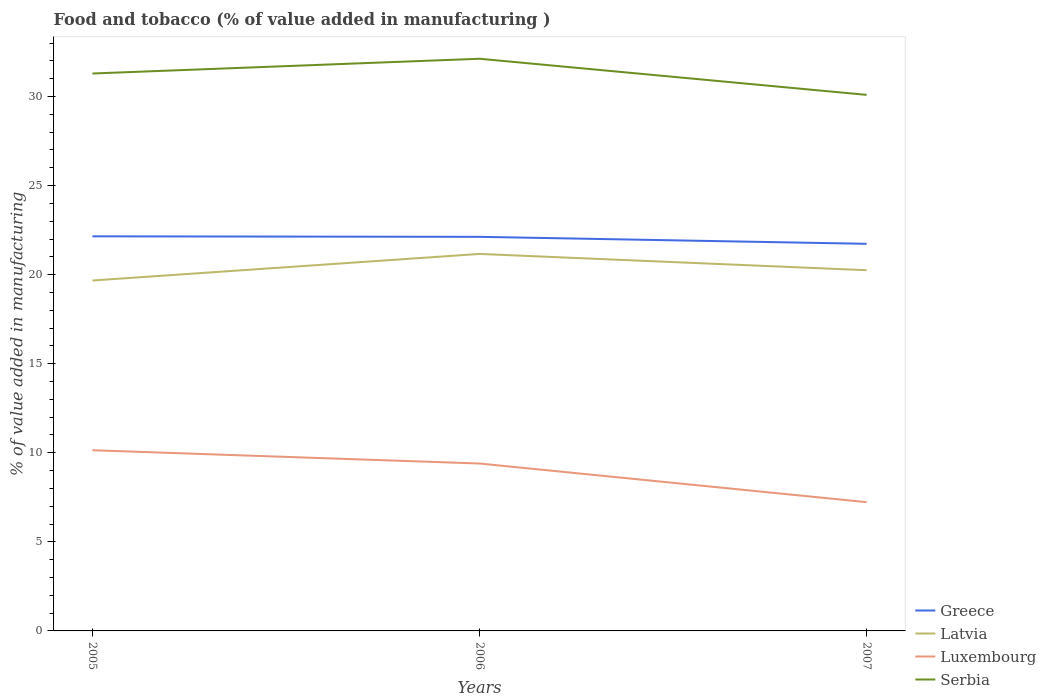How many different coloured lines are there?
Keep it short and to the point. 4. Is the number of lines equal to the number of legend labels?
Provide a succinct answer. Yes. Across all years, what is the maximum value added in manufacturing food and tobacco in Luxembourg?
Your answer should be very brief. 7.23. In which year was the value added in manufacturing food and tobacco in Greece maximum?
Give a very brief answer. 2007. What is the total value added in manufacturing food and tobacco in Luxembourg in the graph?
Provide a succinct answer. 2.91. What is the difference between the highest and the second highest value added in manufacturing food and tobacco in Serbia?
Offer a very short reply. 2.03. How many lines are there?
Your answer should be very brief. 4. What is the difference between two consecutive major ticks on the Y-axis?
Give a very brief answer. 5. Are the values on the major ticks of Y-axis written in scientific E-notation?
Your answer should be compact. No. What is the title of the graph?
Make the answer very short. Food and tobacco (% of value added in manufacturing ). What is the label or title of the Y-axis?
Offer a terse response. % of value added in manufacturing. What is the % of value added in manufacturing of Greece in 2005?
Keep it short and to the point. 22.15. What is the % of value added in manufacturing in Latvia in 2005?
Offer a terse response. 19.67. What is the % of value added in manufacturing of Luxembourg in 2005?
Your answer should be compact. 10.14. What is the % of value added in manufacturing of Serbia in 2005?
Make the answer very short. 31.29. What is the % of value added in manufacturing in Greece in 2006?
Make the answer very short. 22.12. What is the % of value added in manufacturing of Latvia in 2006?
Offer a very short reply. 21.16. What is the % of value added in manufacturing in Luxembourg in 2006?
Provide a short and direct response. 9.4. What is the % of value added in manufacturing of Serbia in 2006?
Your answer should be very brief. 32.12. What is the % of value added in manufacturing in Greece in 2007?
Provide a short and direct response. 21.73. What is the % of value added in manufacturing of Latvia in 2007?
Your response must be concise. 20.25. What is the % of value added in manufacturing of Luxembourg in 2007?
Offer a terse response. 7.23. What is the % of value added in manufacturing of Serbia in 2007?
Make the answer very short. 30.09. Across all years, what is the maximum % of value added in manufacturing in Greece?
Offer a terse response. 22.15. Across all years, what is the maximum % of value added in manufacturing in Latvia?
Ensure brevity in your answer.  21.16. Across all years, what is the maximum % of value added in manufacturing in Luxembourg?
Give a very brief answer. 10.14. Across all years, what is the maximum % of value added in manufacturing of Serbia?
Provide a succinct answer. 32.12. Across all years, what is the minimum % of value added in manufacturing of Greece?
Keep it short and to the point. 21.73. Across all years, what is the minimum % of value added in manufacturing in Latvia?
Provide a short and direct response. 19.67. Across all years, what is the minimum % of value added in manufacturing of Luxembourg?
Offer a very short reply. 7.23. Across all years, what is the minimum % of value added in manufacturing of Serbia?
Your answer should be very brief. 30.09. What is the total % of value added in manufacturing of Greece in the graph?
Make the answer very short. 66.01. What is the total % of value added in manufacturing in Latvia in the graph?
Offer a very short reply. 61.08. What is the total % of value added in manufacturing of Luxembourg in the graph?
Provide a short and direct response. 26.77. What is the total % of value added in manufacturing in Serbia in the graph?
Ensure brevity in your answer.  93.51. What is the difference between the % of value added in manufacturing of Greece in 2005 and that in 2006?
Keep it short and to the point. 0.03. What is the difference between the % of value added in manufacturing in Latvia in 2005 and that in 2006?
Provide a short and direct response. -1.49. What is the difference between the % of value added in manufacturing in Luxembourg in 2005 and that in 2006?
Make the answer very short. 0.75. What is the difference between the % of value added in manufacturing of Serbia in 2005 and that in 2006?
Ensure brevity in your answer.  -0.83. What is the difference between the % of value added in manufacturing in Greece in 2005 and that in 2007?
Make the answer very short. 0.42. What is the difference between the % of value added in manufacturing of Latvia in 2005 and that in 2007?
Give a very brief answer. -0.58. What is the difference between the % of value added in manufacturing of Luxembourg in 2005 and that in 2007?
Your answer should be very brief. 2.91. What is the difference between the % of value added in manufacturing of Serbia in 2005 and that in 2007?
Your response must be concise. 1.2. What is the difference between the % of value added in manufacturing in Greece in 2006 and that in 2007?
Provide a short and direct response. 0.39. What is the difference between the % of value added in manufacturing in Latvia in 2006 and that in 2007?
Your answer should be very brief. 0.91. What is the difference between the % of value added in manufacturing of Luxembourg in 2006 and that in 2007?
Offer a terse response. 2.17. What is the difference between the % of value added in manufacturing of Serbia in 2006 and that in 2007?
Ensure brevity in your answer.  2.03. What is the difference between the % of value added in manufacturing of Greece in 2005 and the % of value added in manufacturing of Latvia in 2006?
Offer a terse response. 0.99. What is the difference between the % of value added in manufacturing of Greece in 2005 and the % of value added in manufacturing of Luxembourg in 2006?
Offer a very short reply. 12.75. What is the difference between the % of value added in manufacturing in Greece in 2005 and the % of value added in manufacturing in Serbia in 2006?
Give a very brief answer. -9.97. What is the difference between the % of value added in manufacturing of Latvia in 2005 and the % of value added in manufacturing of Luxembourg in 2006?
Offer a terse response. 10.27. What is the difference between the % of value added in manufacturing of Latvia in 2005 and the % of value added in manufacturing of Serbia in 2006?
Provide a short and direct response. -12.45. What is the difference between the % of value added in manufacturing of Luxembourg in 2005 and the % of value added in manufacturing of Serbia in 2006?
Make the answer very short. -21.98. What is the difference between the % of value added in manufacturing of Greece in 2005 and the % of value added in manufacturing of Latvia in 2007?
Give a very brief answer. 1.9. What is the difference between the % of value added in manufacturing in Greece in 2005 and the % of value added in manufacturing in Luxembourg in 2007?
Ensure brevity in your answer.  14.92. What is the difference between the % of value added in manufacturing of Greece in 2005 and the % of value added in manufacturing of Serbia in 2007?
Your answer should be very brief. -7.94. What is the difference between the % of value added in manufacturing of Latvia in 2005 and the % of value added in manufacturing of Luxembourg in 2007?
Offer a very short reply. 12.44. What is the difference between the % of value added in manufacturing in Latvia in 2005 and the % of value added in manufacturing in Serbia in 2007?
Give a very brief answer. -10.42. What is the difference between the % of value added in manufacturing in Luxembourg in 2005 and the % of value added in manufacturing in Serbia in 2007?
Offer a terse response. -19.95. What is the difference between the % of value added in manufacturing of Greece in 2006 and the % of value added in manufacturing of Latvia in 2007?
Provide a succinct answer. 1.87. What is the difference between the % of value added in manufacturing of Greece in 2006 and the % of value added in manufacturing of Luxembourg in 2007?
Offer a terse response. 14.89. What is the difference between the % of value added in manufacturing of Greece in 2006 and the % of value added in manufacturing of Serbia in 2007?
Provide a succinct answer. -7.97. What is the difference between the % of value added in manufacturing in Latvia in 2006 and the % of value added in manufacturing in Luxembourg in 2007?
Your response must be concise. 13.93. What is the difference between the % of value added in manufacturing in Latvia in 2006 and the % of value added in manufacturing in Serbia in 2007?
Provide a short and direct response. -8.93. What is the difference between the % of value added in manufacturing in Luxembourg in 2006 and the % of value added in manufacturing in Serbia in 2007?
Your response must be concise. -20.69. What is the average % of value added in manufacturing of Greece per year?
Offer a terse response. 22. What is the average % of value added in manufacturing of Latvia per year?
Your answer should be compact. 20.36. What is the average % of value added in manufacturing of Luxembourg per year?
Provide a succinct answer. 8.92. What is the average % of value added in manufacturing of Serbia per year?
Offer a terse response. 31.17. In the year 2005, what is the difference between the % of value added in manufacturing in Greece and % of value added in manufacturing in Latvia?
Ensure brevity in your answer.  2.48. In the year 2005, what is the difference between the % of value added in manufacturing in Greece and % of value added in manufacturing in Luxembourg?
Offer a very short reply. 12.01. In the year 2005, what is the difference between the % of value added in manufacturing in Greece and % of value added in manufacturing in Serbia?
Keep it short and to the point. -9.14. In the year 2005, what is the difference between the % of value added in manufacturing in Latvia and % of value added in manufacturing in Luxembourg?
Offer a very short reply. 9.53. In the year 2005, what is the difference between the % of value added in manufacturing in Latvia and % of value added in manufacturing in Serbia?
Provide a short and direct response. -11.62. In the year 2005, what is the difference between the % of value added in manufacturing of Luxembourg and % of value added in manufacturing of Serbia?
Make the answer very short. -21.15. In the year 2006, what is the difference between the % of value added in manufacturing in Greece and % of value added in manufacturing in Latvia?
Your response must be concise. 0.96. In the year 2006, what is the difference between the % of value added in manufacturing of Greece and % of value added in manufacturing of Luxembourg?
Offer a very short reply. 12.73. In the year 2006, what is the difference between the % of value added in manufacturing of Greece and % of value added in manufacturing of Serbia?
Your answer should be compact. -10. In the year 2006, what is the difference between the % of value added in manufacturing in Latvia and % of value added in manufacturing in Luxembourg?
Provide a succinct answer. 11.77. In the year 2006, what is the difference between the % of value added in manufacturing of Latvia and % of value added in manufacturing of Serbia?
Offer a very short reply. -10.96. In the year 2006, what is the difference between the % of value added in manufacturing of Luxembourg and % of value added in manufacturing of Serbia?
Ensure brevity in your answer.  -22.72. In the year 2007, what is the difference between the % of value added in manufacturing in Greece and % of value added in manufacturing in Latvia?
Give a very brief answer. 1.48. In the year 2007, what is the difference between the % of value added in manufacturing in Greece and % of value added in manufacturing in Luxembourg?
Offer a very short reply. 14.5. In the year 2007, what is the difference between the % of value added in manufacturing of Greece and % of value added in manufacturing of Serbia?
Provide a succinct answer. -8.36. In the year 2007, what is the difference between the % of value added in manufacturing in Latvia and % of value added in manufacturing in Luxembourg?
Your answer should be compact. 13.02. In the year 2007, what is the difference between the % of value added in manufacturing in Latvia and % of value added in manufacturing in Serbia?
Give a very brief answer. -9.84. In the year 2007, what is the difference between the % of value added in manufacturing of Luxembourg and % of value added in manufacturing of Serbia?
Offer a very short reply. -22.86. What is the ratio of the % of value added in manufacturing in Latvia in 2005 to that in 2006?
Provide a succinct answer. 0.93. What is the ratio of the % of value added in manufacturing of Luxembourg in 2005 to that in 2006?
Give a very brief answer. 1.08. What is the ratio of the % of value added in manufacturing of Serbia in 2005 to that in 2006?
Your answer should be compact. 0.97. What is the ratio of the % of value added in manufacturing of Greece in 2005 to that in 2007?
Provide a short and direct response. 1.02. What is the ratio of the % of value added in manufacturing in Latvia in 2005 to that in 2007?
Your answer should be very brief. 0.97. What is the ratio of the % of value added in manufacturing in Luxembourg in 2005 to that in 2007?
Provide a short and direct response. 1.4. What is the ratio of the % of value added in manufacturing in Serbia in 2005 to that in 2007?
Your answer should be compact. 1.04. What is the ratio of the % of value added in manufacturing in Latvia in 2006 to that in 2007?
Your answer should be very brief. 1.05. What is the ratio of the % of value added in manufacturing in Serbia in 2006 to that in 2007?
Provide a short and direct response. 1.07. What is the difference between the highest and the second highest % of value added in manufacturing in Greece?
Give a very brief answer. 0.03. What is the difference between the highest and the second highest % of value added in manufacturing in Latvia?
Keep it short and to the point. 0.91. What is the difference between the highest and the second highest % of value added in manufacturing in Luxembourg?
Make the answer very short. 0.75. What is the difference between the highest and the second highest % of value added in manufacturing in Serbia?
Your answer should be very brief. 0.83. What is the difference between the highest and the lowest % of value added in manufacturing of Greece?
Keep it short and to the point. 0.42. What is the difference between the highest and the lowest % of value added in manufacturing in Latvia?
Provide a succinct answer. 1.49. What is the difference between the highest and the lowest % of value added in manufacturing of Luxembourg?
Your answer should be compact. 2.91. What is the difference between the highest and the lowest % of value added in manufacturing of Serbia?
Your answer should be very brief. 2.03. 